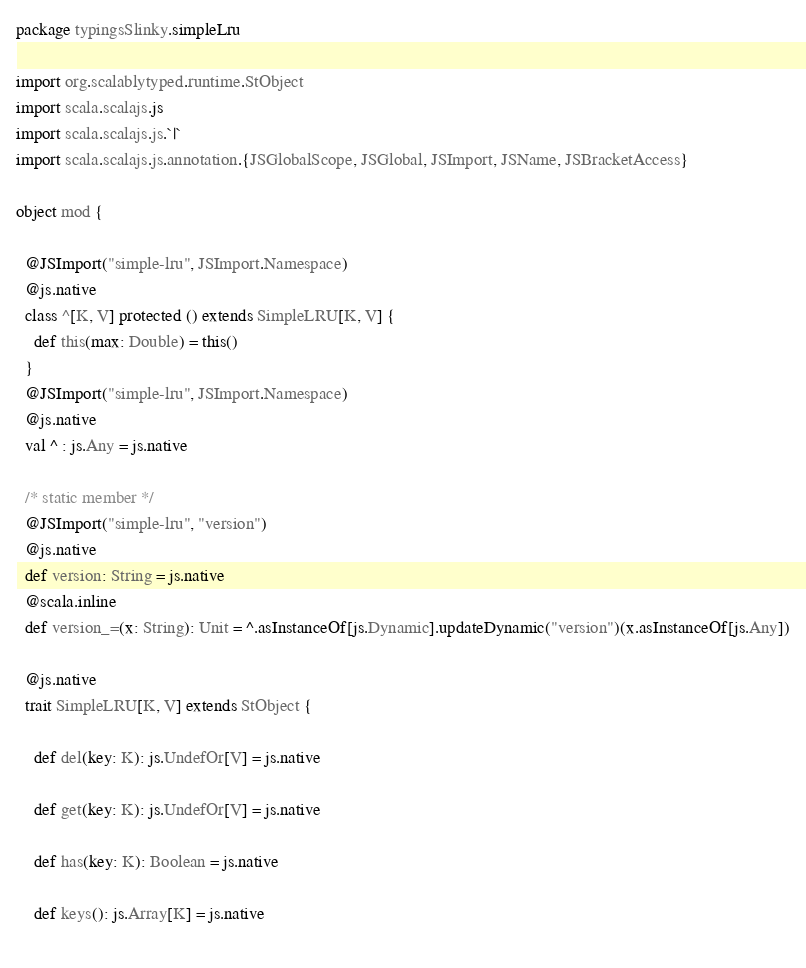<code> <loc_0><loc_0><loc_500><loc_500><_Scala_>package typingsSlinky.simpleLru

import org.scalablytyped.runtime.StObject
import scala.scalajs.js
import scala.scalajs.js.`|`
import scala.scalajs.js.annotation.{JSGlobalScope, JSGlobal, JSImport, JSName, JSBracketAccess}

object mod {
  
  @JSImport("simple-lru", JSImport.Namespace)
  @js.native
  class ^[K, V] protected () extends SimpleLRU[K, V] {
    def this(max: Double) = this()
  }
  @JSImport("simple-lru", JSImport.Namespace)
  @js.native
  val ^ : js.Any = js.native
  
  /* static member */
  @JSImport("simple-lru", "version")
  @js.native
  def version: String = js.native
  @scala.inline
  def version_=(x: String): Unit = ^.asInstanceOf[js.Dynamic].updateDynamic("version")(x.asInstanceOf[js.Any])
  
  @js.native
  trait SimpleLRU[K, V] extends StObject {
    
    def del(key: K): js.UndefOr[V] = js.native
    
    def get(key: K): js.UndefOr[V] = js.native
    
    def has(key: K): Boolean = js.native
    
    def keys(): js.Array[K] = js.native
    </code> 